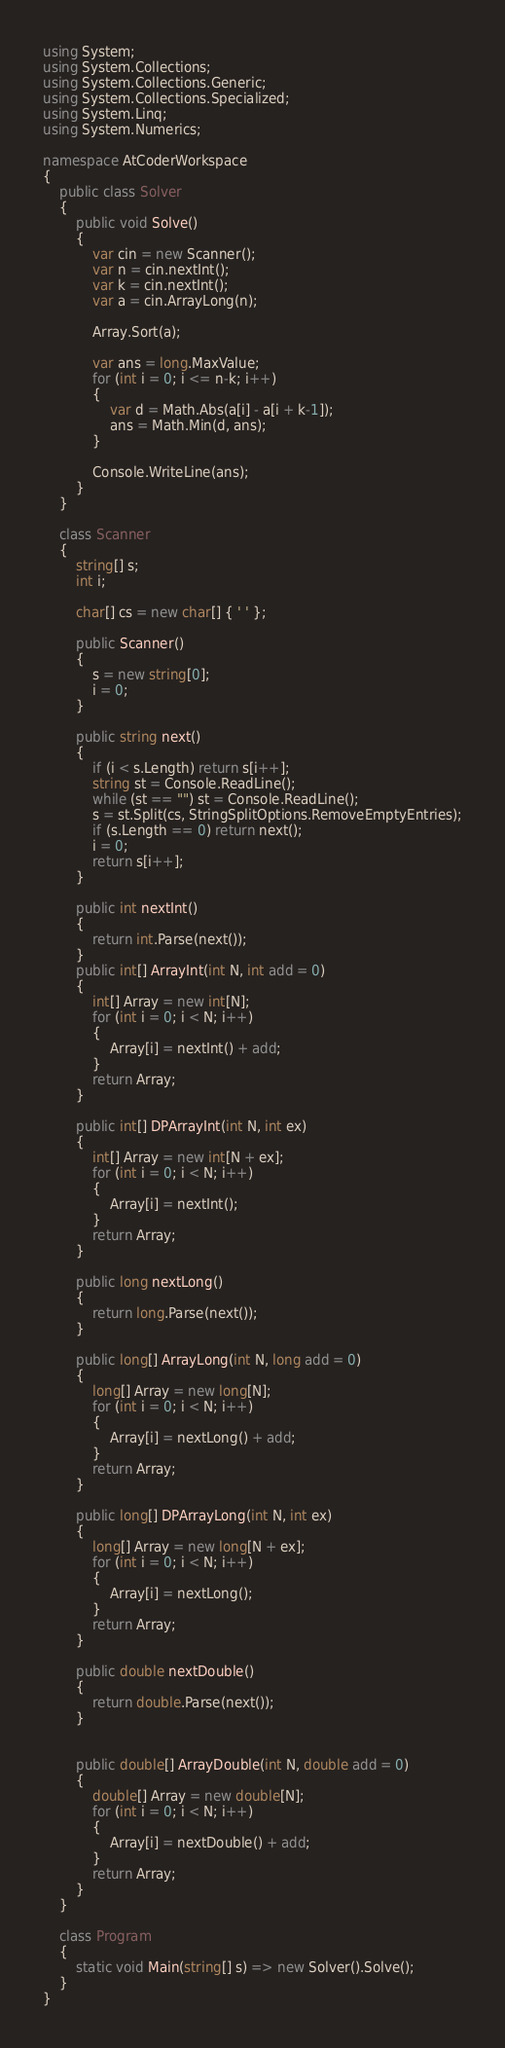<code> <loc_0><loc_0><loc_500><loc_500><_C#_>using System;
using System.Collections;
using System.Collections.Generic;
using System.Collections.Specialized;
using System.Linq;
using System.Numerics;

namespace AtCoderWorkspace
{
    public class Solver
    {
        public void Solve()
        {
            var cin = new Scanner();
            var n = cin.nextInt();
            var k = cin.nextInt();
            var a = cin.ArrayLong(n);

            Array.Sort(a);

            var ans = long.MaxValue;
            for (int i = 0; i <= n-k; i++)
            {
                var d = Math.Abs(a[i] - a[i + k-1]);
                ans = Math.Min(d, ans);
            }
            
            Console.WriteLine(ans);
        }
    }

    class Scanner
    {
        string[] s;
        int i;

        char[] cs = new char[] { ' ' };

        public Scanner()
        {
            s = new string[0];
            i = 0;
        }

        public string next()
        {
            if (i < s.Length) return s[i++];
            string st = Console.ReadLine();
            while (st == "") st = Console.ReadLine();
            s = st.Split(cs, StringSplitOptions.RemoveEmptyEntries);
            if (s.Length == 0) return next();
            i = 0;
            return s[i++];
        }

        public int nextInt()
        {
            return int.Parse(next());
        }
        public int[] ArrayInt(int N, int add = 0)
        {
            int[] Array = new int[N];
            for (int i = 0; i < N; i++)
            {
                Array[i] = nextInt() + add;
            }
            return Array;
        }

        public int[] DPArrayInt(int N, int ex)
        {
            int[] Array = new int[N + ex];
            for (int i = 0; i < N; i++)
            {
                Array[i] = nextInt();
            }
            return Array;
        }

        public long nextLong()
        {
            return long.Parse(next());
        }

        public long[] ArrayLong(int N, long add = 0)
        {
            long[] Array = new long[N];
            for (int i = 0; i < N; i++)
            {
                Array[i] = nextLong() + add;
            }
            return Array;
        }

        public long[] DPArrayLong(int N, int ex)
        {
            long[] Array = new long[N + ex];
            for (int i = 0; i < N; i++)
            {
                Array[i] = nextLong();
            }
            return Array;
        }

        public double nextDouble()
        {
            return double.Parse(next());
        }


        public double[] ArrayDouble(int N, double add = 0)
        {
            double[] Array = new double[N];
            for (int i = 0; i < N; i++)
            {
                Array[i] = nextDouble() + add;
            }
            return Array;
        }
    }

    class Program
    {
        static void Main(string[] s) => new Solver().Solve();
    }
}
</code> 